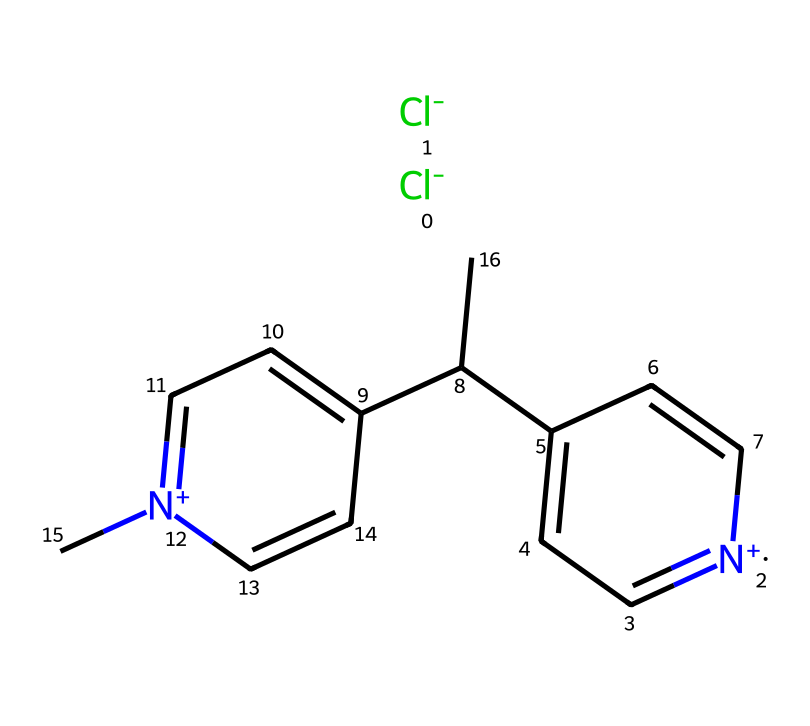What is the molecular formula of paraquat? To determine the molecular formula from the SMILES representation, we identify the various atoms present and their counts. The structure includes one nitrogen atom in a positive state and multiple carbon atoms. Upon counting, there are 14 carbon atoms, 2 nitrogen atoms, and 2 chlorine atoms in total. Therefore, the molecular formula is C12H14Cl2N2.
Answer: C12H14Cl2N2 How many chlorine atoms are in paraquat? By analyzing the SMILES representation, we can see there are two instances of [Cl-], indicating 2 chlorine atoms are present in the structure.
Answer: 2 What functional groups are present in paraquat? In paraquat's structure, the presence of quaternary ammonium indicated by the nitrogen atoms, and aromatic rings represented by the cyclic carbon structures are identified as its main functional groups.
Answer: quaternary ammonium, aromatic rings What type of herbicide is paraquat classified as? Paraquat is classified as a non-selective herbicide because it kills a wide range of plants rather than targeting specific weeds. This classification is due to its chemical structure allowing it to disrupt the photosynthesis process in many plant species.
Answer: non-selective What is the key aspect of paraquat's toxicity? Paraquat is highly toxic due to its ability to generate reactive oxygen species that result in oxidative stress, damaging cellular structures, particularly in lung tissues. This mechanism of action contributes to its acute toxicity to humans and animals.
Answer: reactive oxygen species How does the chemical structure of paraquat relate to its herbicidal action? The structure of paraquat, particularly its positively charged nitrogen and aromatic components, allows it to interact effectively with plant cell components, leading to its herbicidal activity by disrupting photosynthesis. This interaction is critical for its functionality as a herbicide.
Answer: interaction with plant cell components 